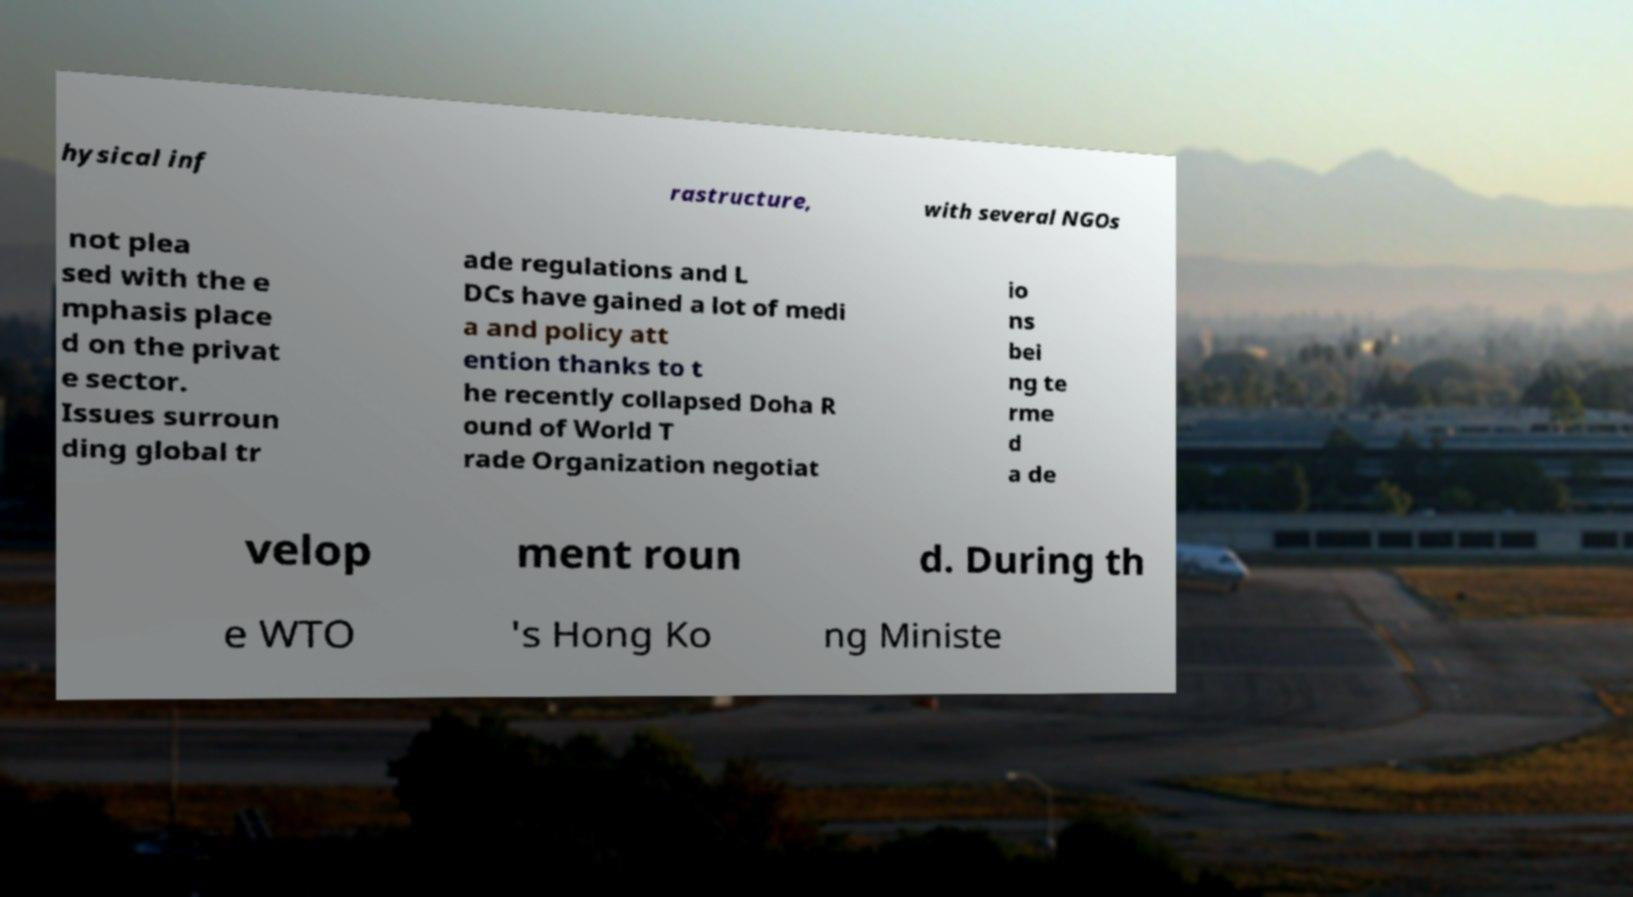I need the written content from this picture converted into text. Can you do that? hysical inf rastructure, with several NGOs not plea sed with the e mphasis place d on the privat e sector. Issues surroun ding global tr ade regulations and L DCs have gained a lot of medi a and policy att ention thanks to t he recently collapsed Doha R ound of World T rade Organization negotiat io ns bei ng te rme d a de velop ment roun d. During th e WTO 's Hong Ko ng Ministe 